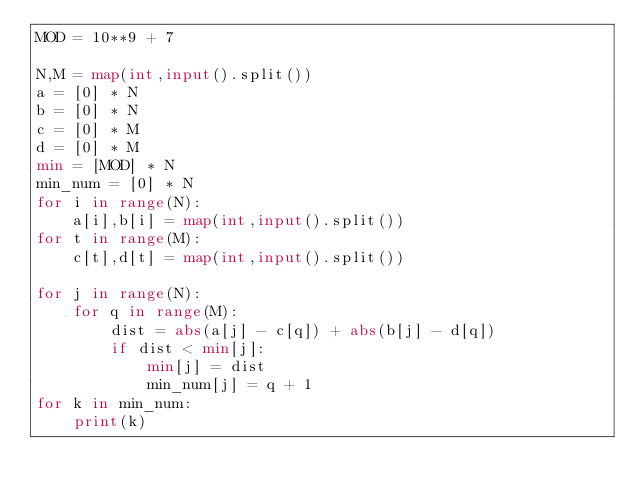Convert code to text. <code><loc_0><loc_0><loc_500><loc_500><_Python_>MOD = 10**9 + 7

N,M = map(int,input().split())
a = [0] * N
b = [0] * N
c = [0] * M
d = [0] * M
min = [MOD] * N
min_num = [0] * N
for i in range(N):
    a[i],b[i] = map(int,input().split())
for t in range(M):
    c[t],d[t] = map(int,input().split())

for j in range(N):
    for q in range(M):
        dist = abs(a[j] - c[q]) + abs(b[j] - d[q])
        if dist < min[j]:
            min[j] = dist
            min_num[j] = q + 1
for k in min_num:
    print(k)
</code> 